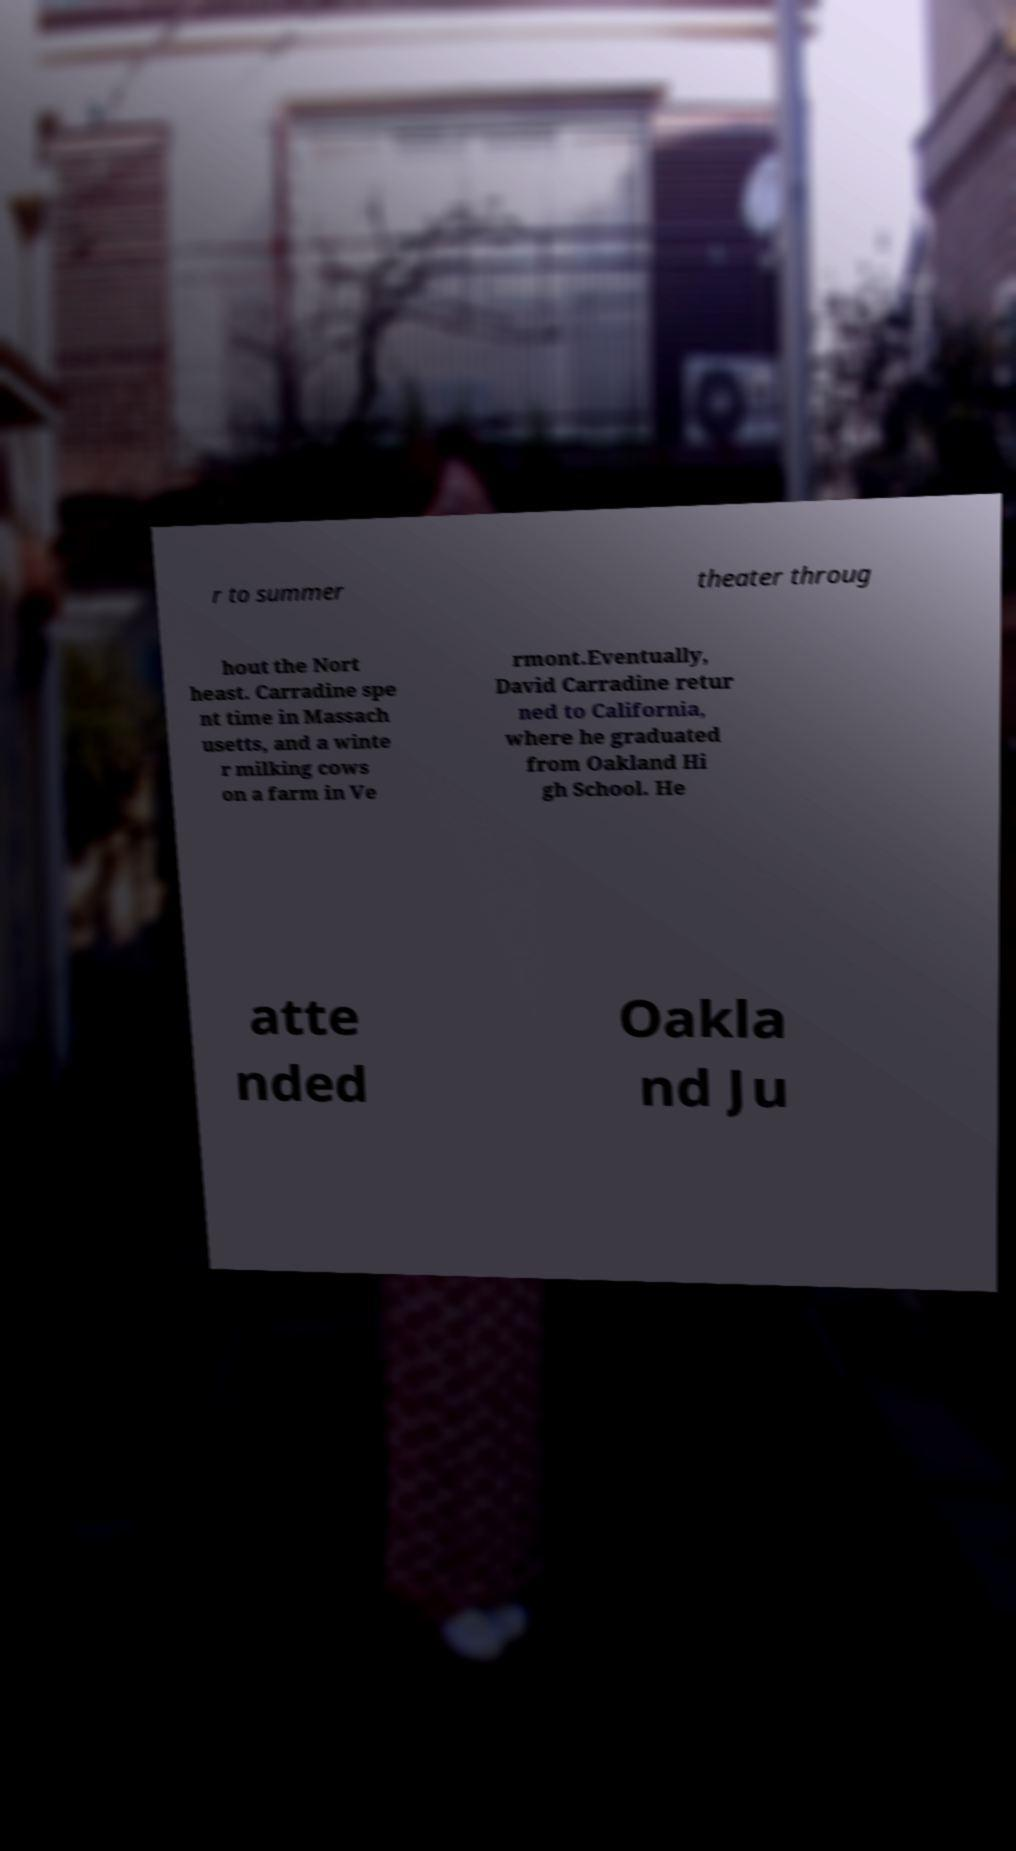Can you read and provide the text displayed in the image?This photo seems to have some interesting text. Can you extract and type it out for me? r to summer theater throug hout the Nort heast. Carradine spe nt time in Massach usetts, and a winte r milking cows on a farm in Ve rmont.Eventually, David Carradine retur ned to California, where he graduated from Oakland Hi gh School. He atte nded Oakla nd Ju 